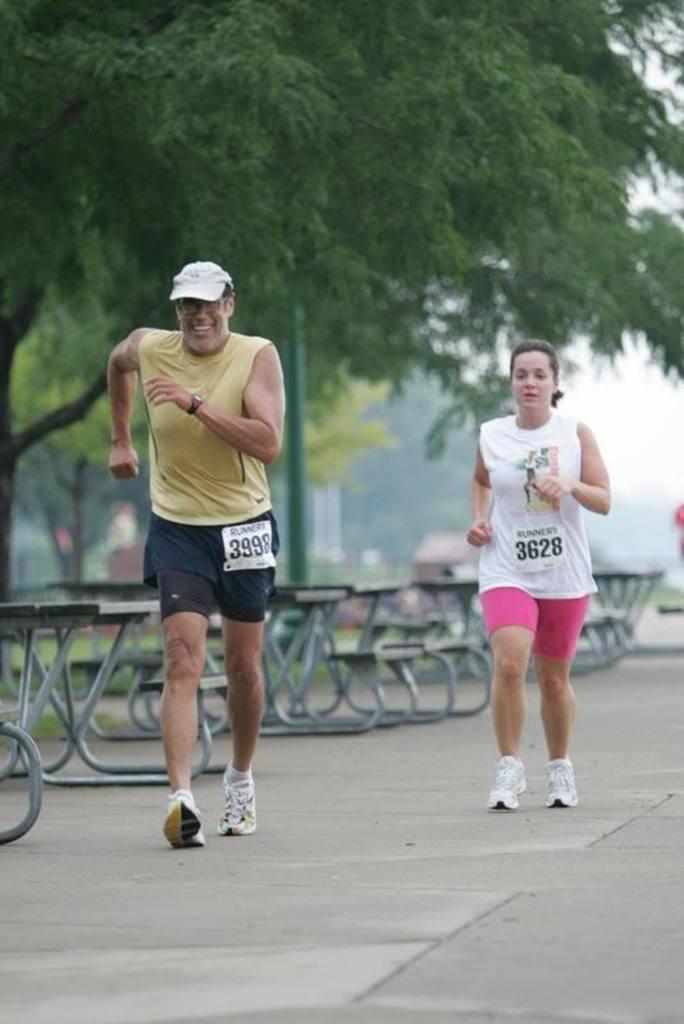How would you summarize this image in a sentence or two? As we can see in the image there are two people, benches, trees, sky and in the background there is a house. 